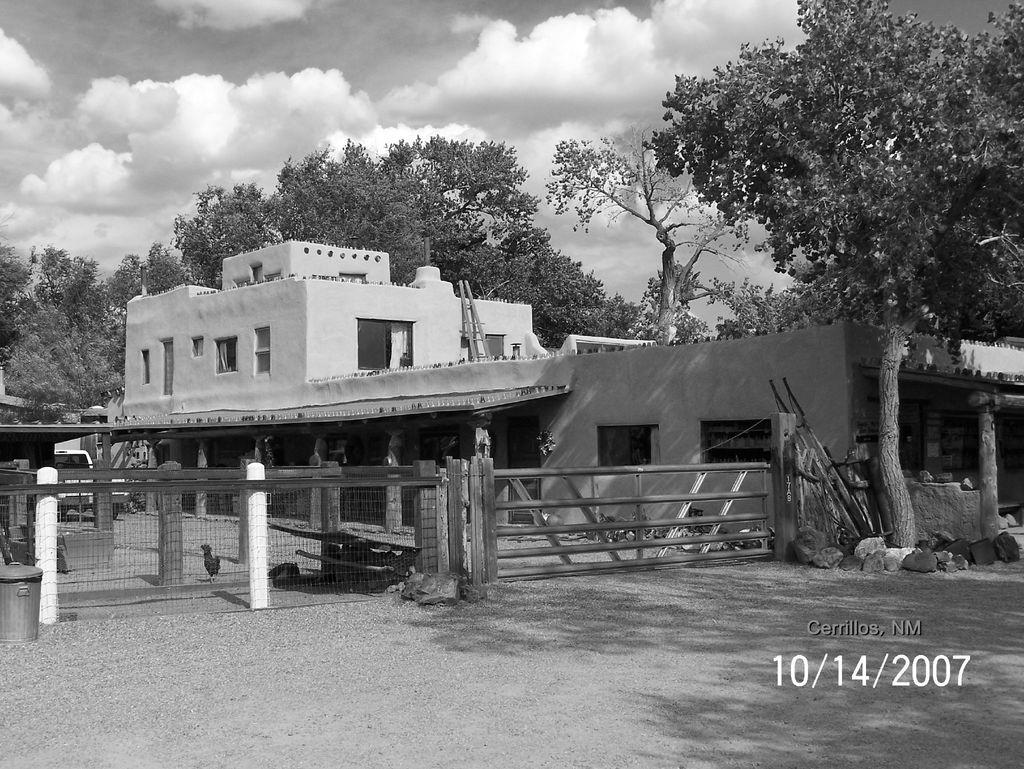What type of structures are present in the image? There are houses in the image. What features can be seen on the houses? The houses have windows. What type of barrier is present in the image? There is a fence in the image. Is there a way to enter or exit the area with the houses? Yes, there is a gate in the image. What type of vegetation is present in the image? There are trees in the image. What is on the ground in the image? There is a vehicle on the ground in the image. What can be seen in the background of the image? The sky is visible in the background of the image. What is the condition of the sky in the image? There are clouds in the sky. Can you tell me how many bears are sitting on the roof of the houses in the image? There are no bears present in the image; it features houses, a fence, a gate, trees, a vehicle, and a sky with clouds. What type of juice is being served in the image? There is no juice present in the image. 